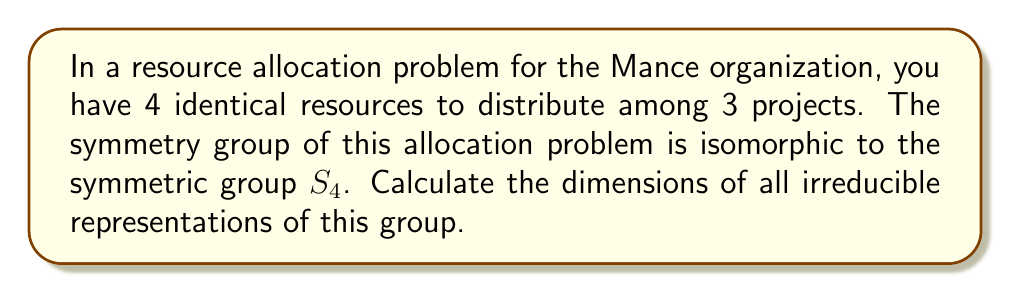Provide a solution to this math problem. To solve this problem, we'll follow these steps:

1) First, recall that the irreducible representations of the symmetric group $S_n$ are in one-to-one correspondence with partitions of $n$.

2) For $S_4$, the partitions are:
   $[4]$, $[3,1]$, $[2,2]$, $[2,1,1]$, and $[1,1,1,1]$

3) To calculate the dimensions of these representations, we can use the hook length formula:

   $$\dim(\lambda) = \frac{n!}{\prod_{(i,j)\in \lambda} h(i,j)}$$

   where $\lambda$ is the partition, $n$ is the number being partitioned (4 in this case), and $h(i,j)$ is the hook length of the cell $(i,j)$ in the Young diagram.

4) Let's calculate for each partition:

   a) For $[4]$: 
      Hook lengths: 4, 3, 2, 1
      $$\dim([4]) = \frac{4!}{4 \cdot 3 \cdot 2 \cdot 1} = 1$$

   b) For $[3,1]$:
      Hook lengths: 4, 2, 1, 1
      $$\dim([3,1]) = \frac{4!}{4 \cdot 2 \cdot 1 \cdot 1} = 3$$

   c) For $[2,2]$:
      Hook lengths: 3, 2, 2, 1
      $$\dim([2,2]) = \frac{4!}{3 \cdot 2 \cdot 2 \cdot 1} = 2$$

   d) For $[2,1,1]$:
      Hook lengths: 3, 1, 1, 1
      $$\dim([2,1,1]) = \frac{4!}{3 \cdot 1 \cdot 1 \cdot 1} = 3$$

   e) For $[1,1,1,1]$:
      Hook lengths: 1, 1, 1, 1
      $$\dim([1,1,1,1]) = \frac{4!}{1 \cdot 1 \cdot 1 \cdot 1} = 1$$

5) Therefore, the dimensions of the irreducible representations are 1, 3, 2, 3, and 1.
Answer: 1, 3, 2, 3, 1 